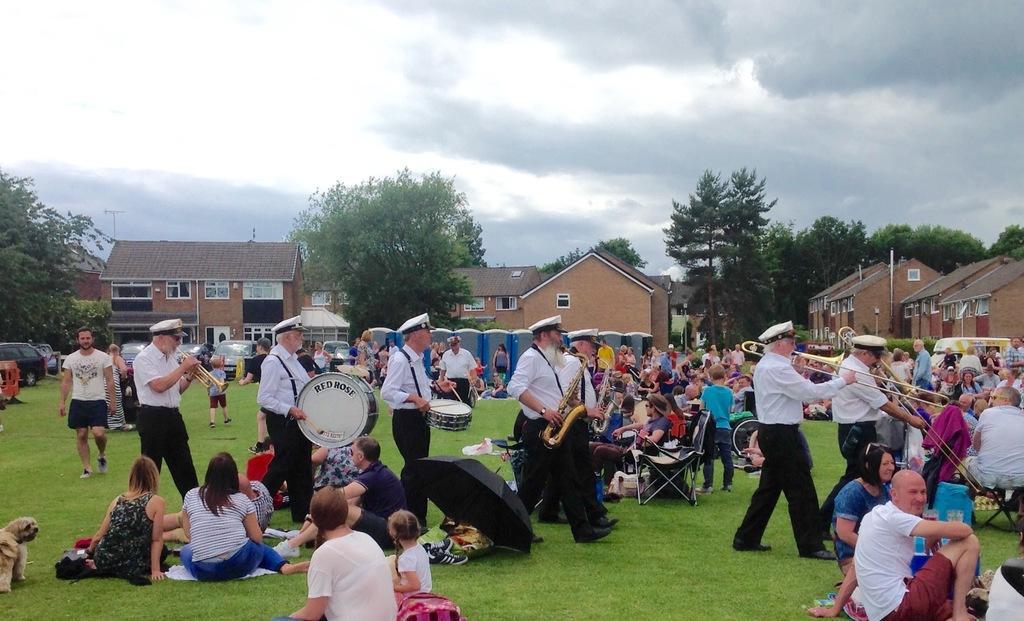Can you describe this image briefly? This image is taken outdoors. At the top of the image there is the sky with clouds. At the bottom of the image there is a ground with grass on it. In the background there are many trees with leaves, stems and branches. There are many houses. A few cars are parked on the ground. In the middle of the image many people are sitting on the ground and a few are sitting on the chairs. Many people are walking on the ground and a few are standing. A few people are holding musical instruments in their hands and playing music. There are a few tables with a few things on them. 